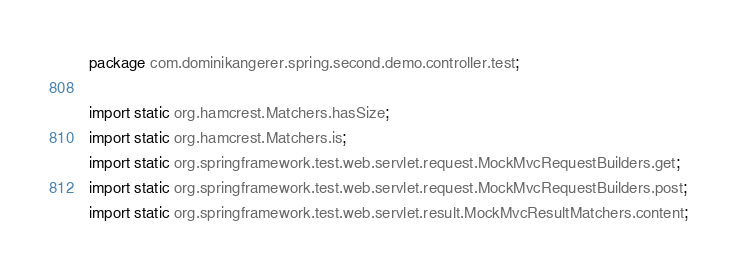Convert code to text. <code><loc_0><loc_0><loc_500><loc_500><_Java_>package com.dominikangerer.spring.second.demo.controller.test;

import static org.hamcrest.Matchers.hasSize;
import static org.hamcrest.Matchers.is;
import static org.springframework.test.web.servlet.request.MockMvcRequestBuilders.get;
import static org.springframework.test.web.servlet.request.MockMvcRequestBuilders.post;
import static org.springframework.test.web.servlet.result.MockMvcResultMatchers.content;</code> 